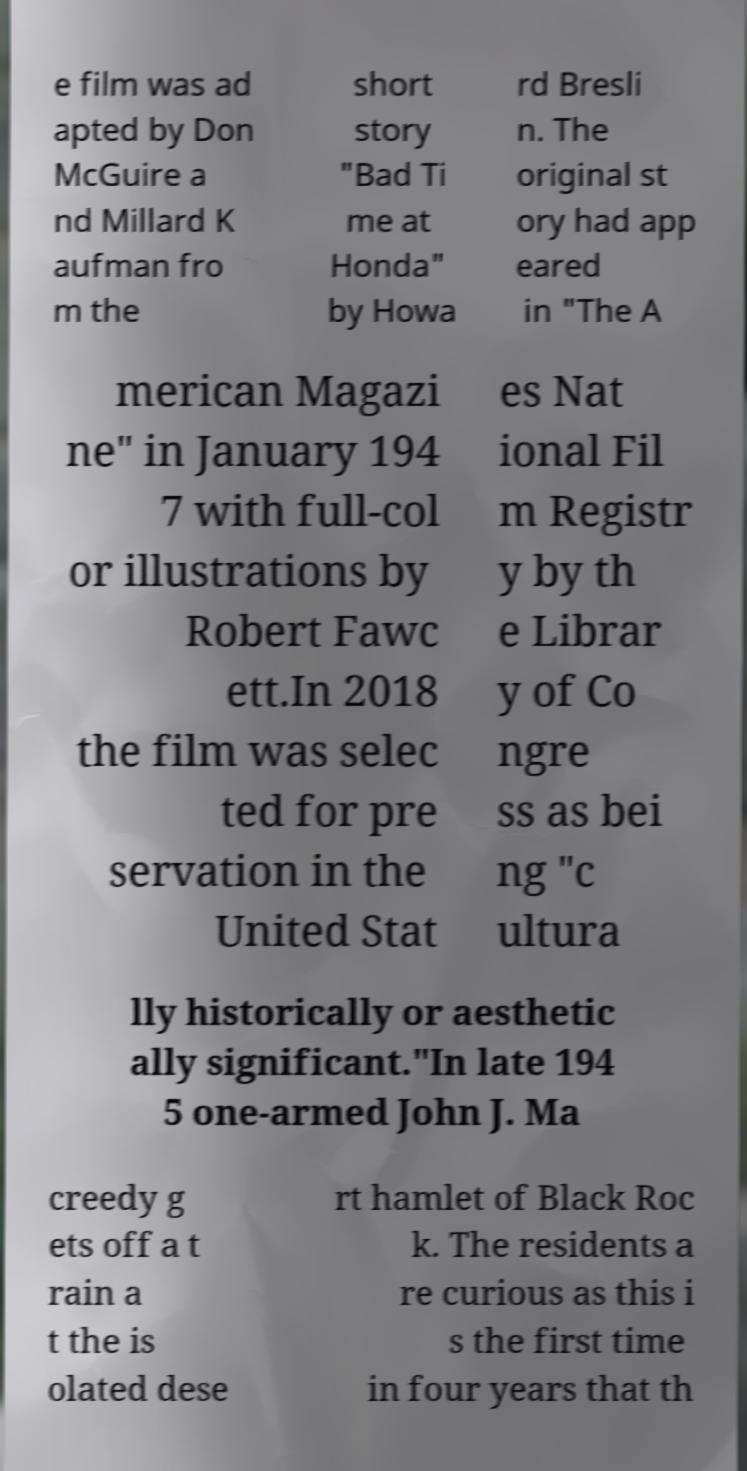For documentation purposes, I need the text within this image transcribed. Could you provide that? e film was ad apted by Don McGuire a nd Millard K aufman fro m the short story "Bad Ti me at Honda" by Howa rd Bresli n. The original st ory had app eared in "The A merican Magazi ne" in January 194 7 with full-col or illustrations by Robert Fawc ett.In 2018 the film was selec ted for pre servation in the United Stat es Nat ional Fil m Registr y by th e Librar y of Co ngre ss as bei ng "c ultura lly historically or aesthetic ally significant."In late 194 5 one-armed John J. Ma creedy g ets off a t rain a t the is olated dese rt hamlet of Black Roc k. The residents a re curious as this i s the first time in four years that th 